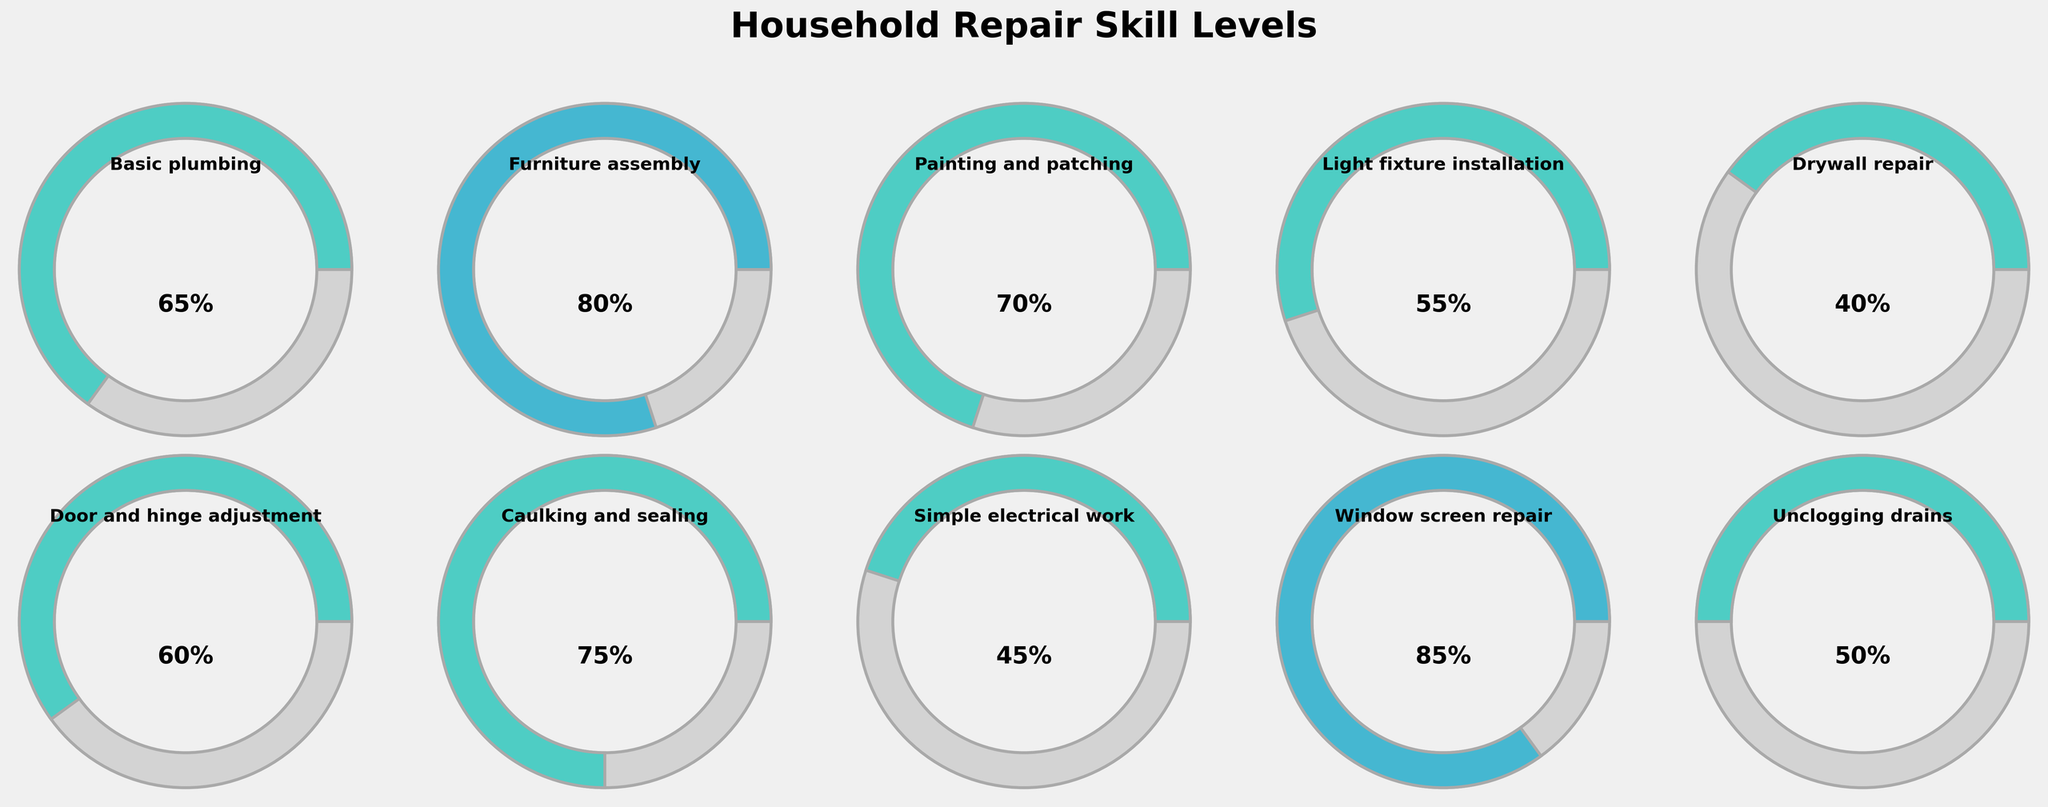What is the title of the figure? The title of the figure is located at the top center of the image and it reads "Household Repair Skill Levels".
Answer: Household Repair Skill Levels Which skill has the highest level? By comparing the gauge fills for each skill, the skill with the fullest gauge is "Window screen repair" with a level of 85.
Answer: Window screen repair What is the skill level for Light fixture installation? Look for the gauge chart labeled "Light fixture installation" and read off the percentage level. It shows 55%.
Answer: 55% How many skills have a level above 70%? Identify all gauges with more than 70% filled and count them. The skills are "Furniture assembly" (80%), "Caulking and sealing" (75%), and "Window screen repair" (85%). There are three of them.
Answer: 3 What is the combined skill level for Basic plumbing and Door and hinge adjustment? Add the skill levels for Basic plumbing (65) and Door and hinge adjustment (60). 65 + 60 = 125.
Answer: 125 Which skill has a lower level: Simple electrical work or Unclogging drains? Compare the levels of Simple electrical work (45%) and Unclogging drains (50%). Simple electrical work has a lower level.
Answer: Simple electrical work Are there any skills with levels below 50%? If so, which ones? Identify any gauges with less than half filled. "Drywall repair" (40%) and "Simple electrical work" (45%) have levels below 50%.
Answer: Drywall repair, Simple electrical work What is the average skill level for the given household repairs? Sum all 10 skill levels: 65 + 80 + 70 + 55 + 40 + 60 + 75 + 45 + 85 + 50 = 625. Then divide by the number of skills (10). The average is 625 / 10 = 62.5.
Answer: 62.5 How many skills fall into the 40-60% range? Identify all gauges where the percentage falls between 40 to 60. The skills are "Simple electrical work" (45%), "Unclogging drains" (50%), "Light fixture installation" (55%), and "Door and hinge adjustment" (60%). There are four skills.
Answer: 4 Which skill level is closer to its maximum at 100%? The skill with the highest level and hence closer to 100% is "Window screen repair" with an 85% level.
Answer: Window screen repair 